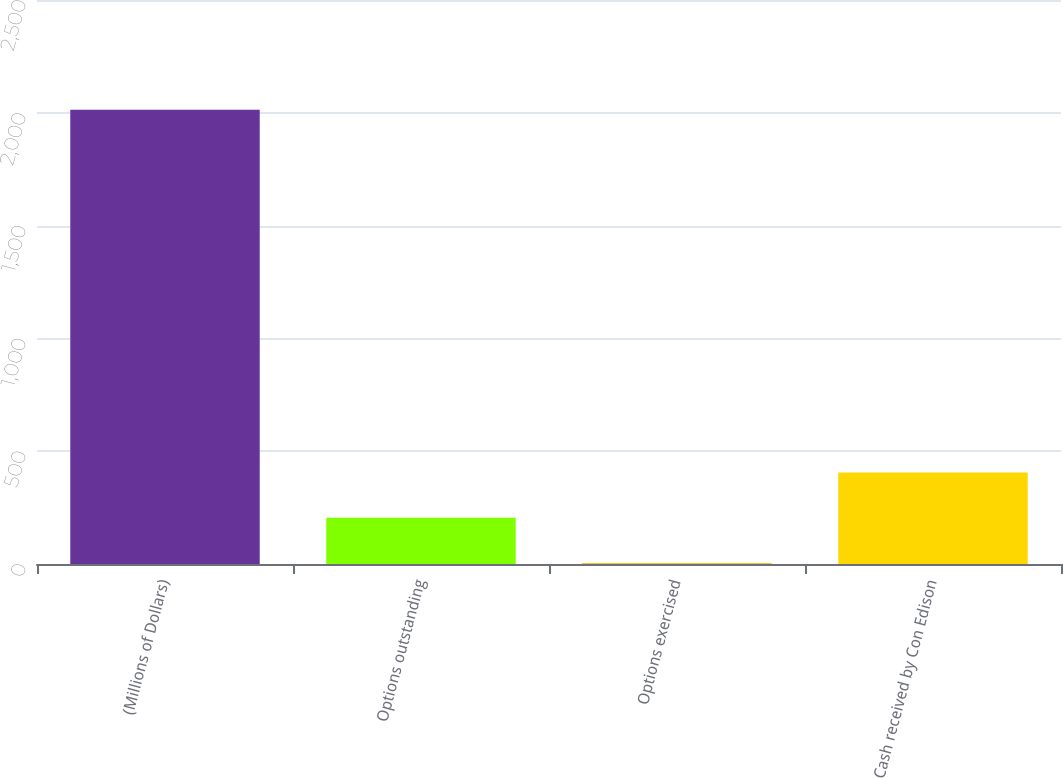Convert chart. <chart><loc_0><loc_0><loc_500><loc_500><bar_chart><fcel>(Millions of Dollars)<fcel>Options outstanding<fcel>Options exercised<fcel>Cash received by Con Edison<nl><fcel>2014<fcel>205<fcel>4<fcel>406<nl></chart> 